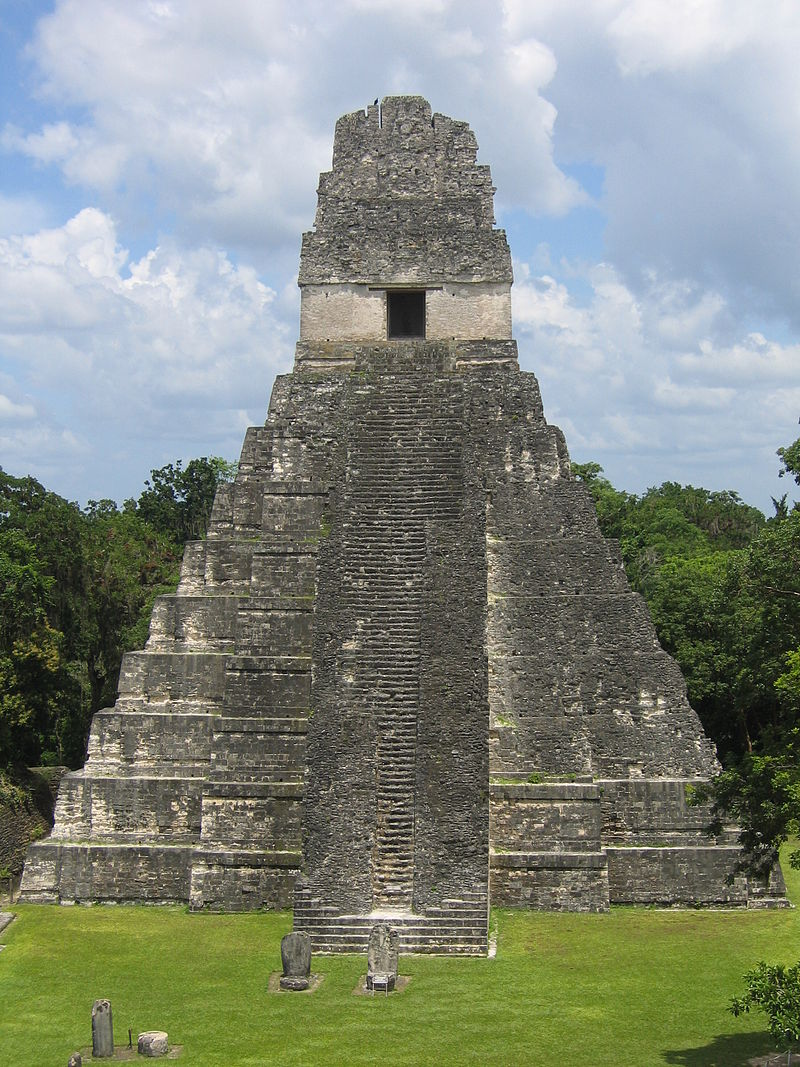Create a short story about an ancient Mayan ceremony performed at Tikal Temple I. The brisk morning air was laden with anticipation as the Mayan city of Tikal prepared for the grand ceremony. At the break of dawn, priests adorned in elaborate feathers and jade jewelry climbed the steep staircase of Tikal Temple I. Below, the citizens gathered, their eyes fixated on the pinnacle of the temple where the High Priest would align with the rising sun. As the first rays of the sun illuminated the top temple, the High Priest began chanting in a deep, resonant voice. The crowd below echoed his words, offering their prayers to the gods for bountiful harvests and protection. Incense filled the air, and the rhythmic sound of drums and conch shells created a hypnotic symphony. Amidst the sacred rituals, offerings of maize, cacao, and jade were presented at the altars, cementing the profound connection between the heavens and the earth. 